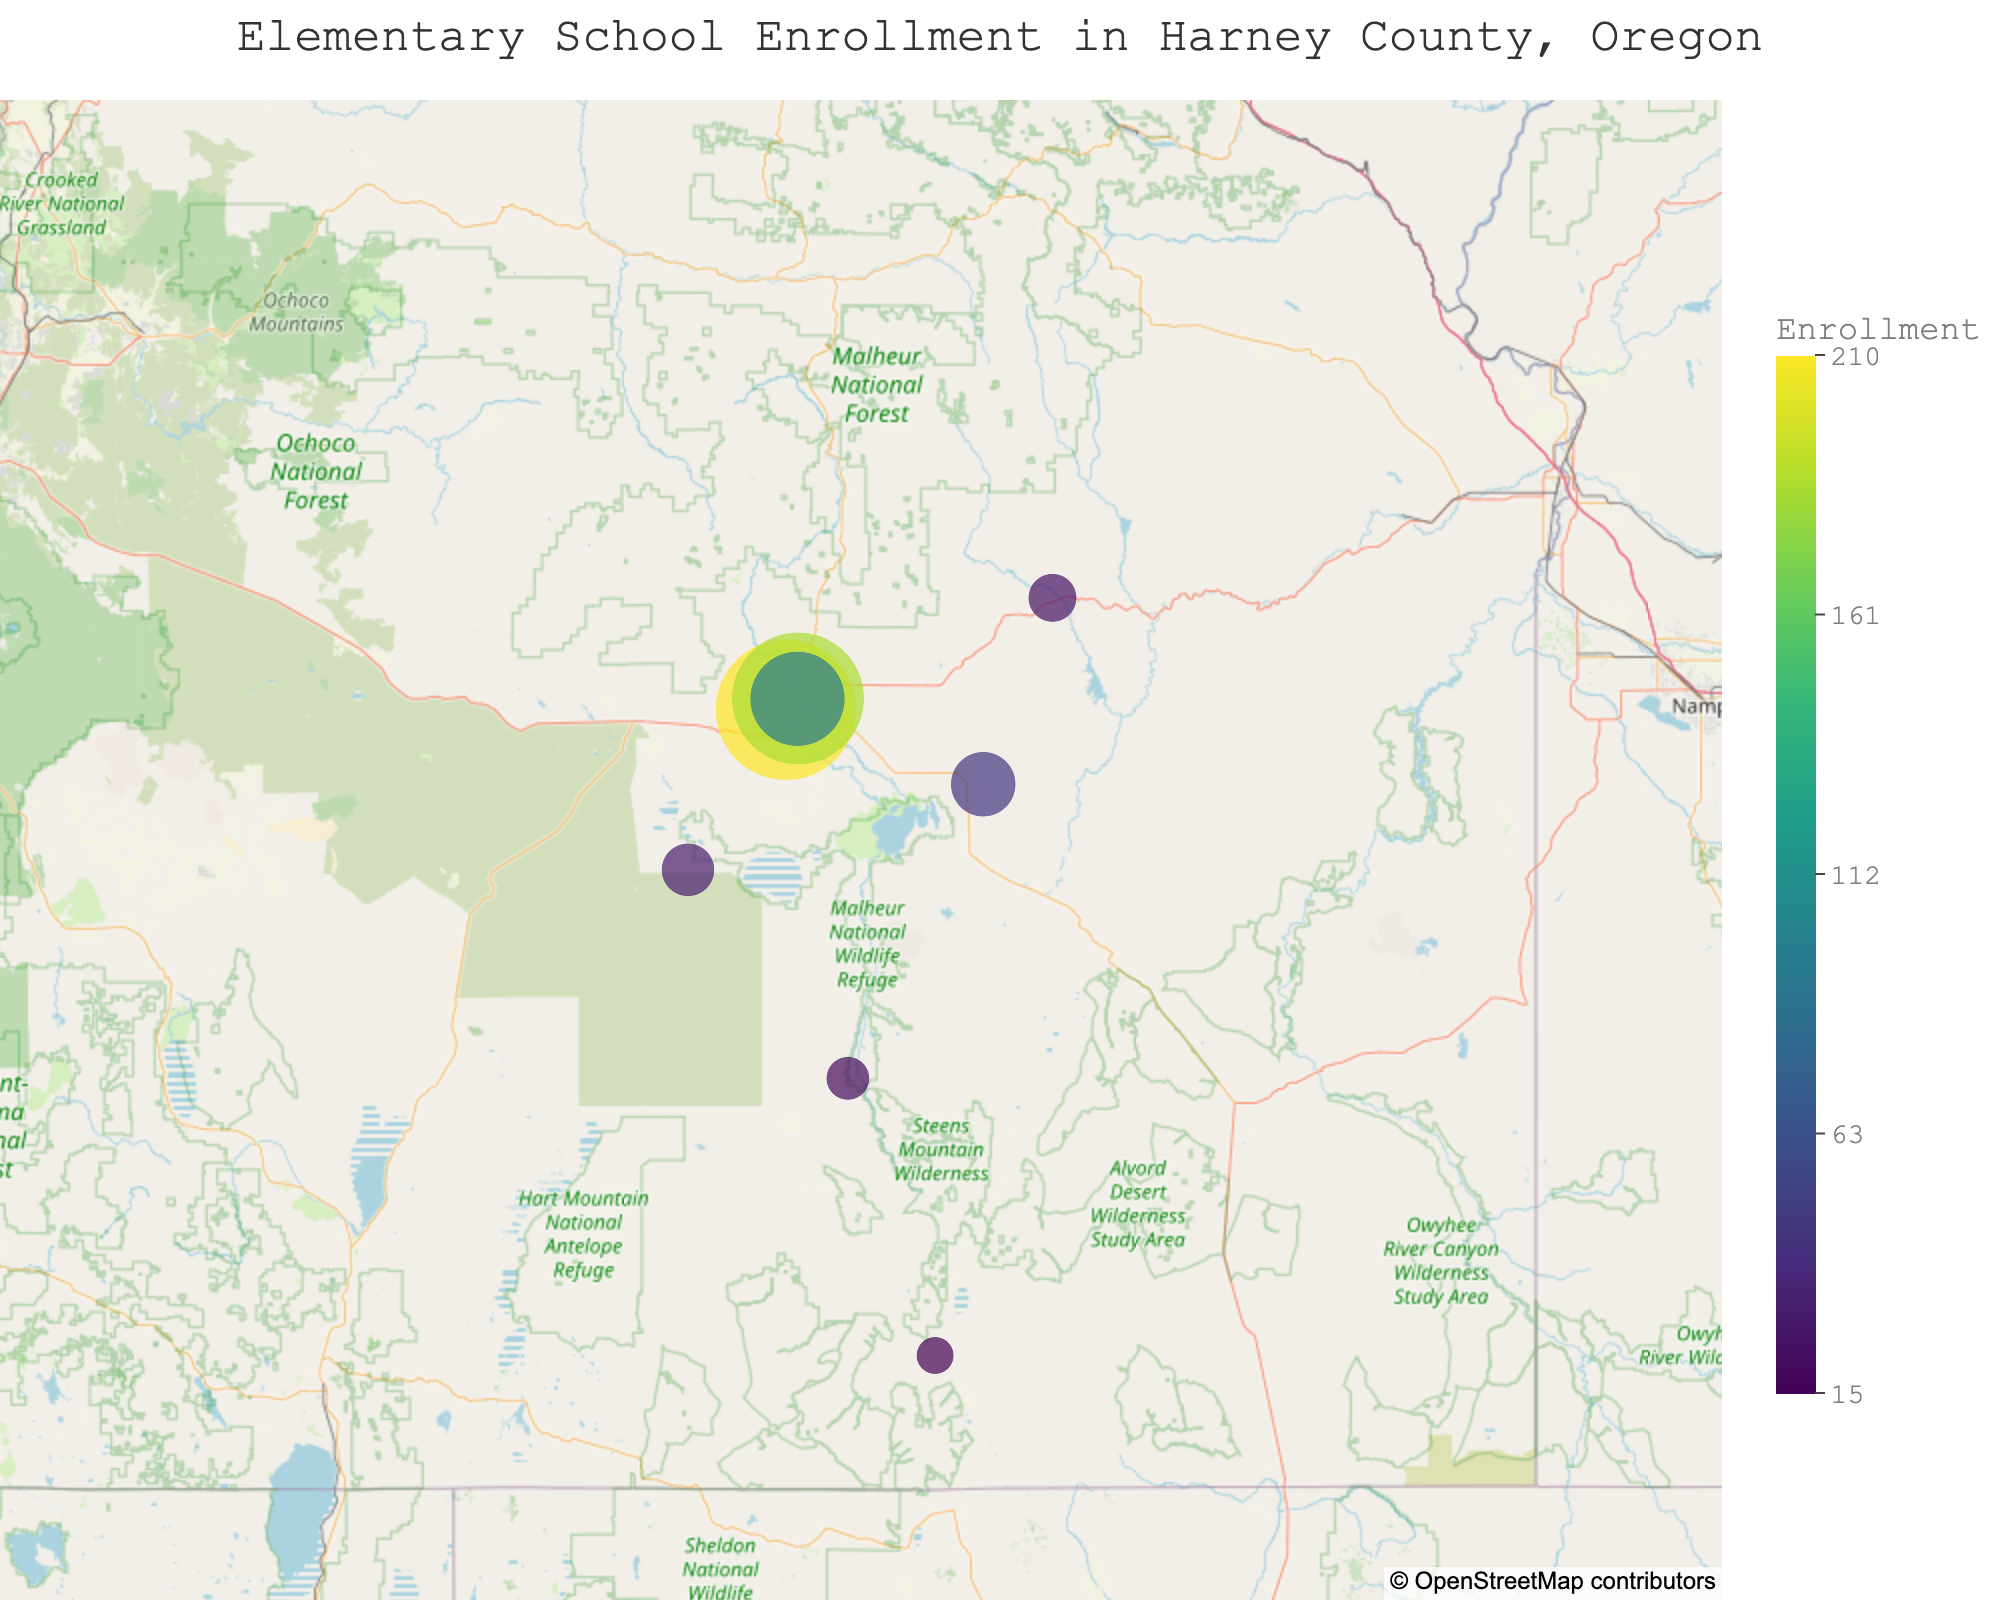What is the title of the figure? The title of the figure is typically displayed at the top of the chart, and in this case, it is "Elementary School Enrollment in Harney County, Oregon" as specified in the code.
Answer: Elementary School Enrollment in Harney County, Oregon Which school has the highest enrollment of students? The size of the circle and the color intensity on the map indicate the number of students. The school with the largest circle and the most intense color corresponds to the highest enrollment. According to the data, Hines Middle School has the highest enrollment of 210 students.
Answer: Hines Middle School How many schools have an enrollment greater than 100 students? To answer this, count the schools displayed on the map with larger circles and more intense colors. Based on the data, there are three schools with enrollments greater than 100: Hines Middle School (210), Slater Elementary School (185), and Burns High School (95, which is not greater than 100 but close). Thus, there are 2 schools.
Answer: 2 Which school is located at the southernmost point on the map, and what is its enrollment? The southernmost school can be identified by looking at the school furthest down on the map. According to the data and location coordinates, Fields School is the southernmost and has 15 students enrolled.
Answer: Fields School, 15 What is the average enrollment of all the schools in the plot? Calculate the average by summing all the enrollments and dividing by the number of schools. The total enrollment is 210 + 185 + 95 + 45 + 25 + 15 + 20 + 30 = 625. There are 8 schools. Therefore, the average enrollment is 625 / 8 = 78.125.
Answer: 78.125 Which school has the smallest enrollment, and how can you identify it on the map? The smallest enrollment is indicated by the smallest circle and the least intense color. In the data, Fields School has the smallest enrollment of 15 students.
Answer: Fields School How does the enrollment of Drewsey School compare to Crane Elementary School? To compare, look at the size and color of the circles for both schools. Drewsey School has an enrollment of 25 students, and Crane Elementary School has an enrollment of 45 students. Thus, Crane Elementary has more students.
Answer: Crane Elementary School has more students What is the latitudinal range covered by the schools in the plot? To find the latitudinal range, identify the northernmost and southernmost schools and their latitudes. Drewsey School at 43.7859 is the northernmost, and Fields School at 42.2648 is the southernmost. The latitudinal range is 43.7859 - 42.2648 = 1.5211.
Answer: 1.5211 What is the geographic center (latitude and longitude) of the schools in the plot? The center can be calculated by averaging the latitudes and longitudes of all the schools. The average latitude is (43.5637 + 43.5861 + 43.5854 + 43.4153 + 43.7859 + 42.2648 + 42.8256 + 43.2442) / 8 ≈ 43.1589, and the average longitude is (-119.0862 + -119.0533 + -119.0546 + -118.5447 + -118.3545 + -118.6767 + -118.9164 + -119.3556) / 8 ≈ -118.8804. Therefore, the geographic center is approximately at latitude 43.1589 and longitude -118.8804.
Answer: Latitude 43.1589, Longitude -118.8804 